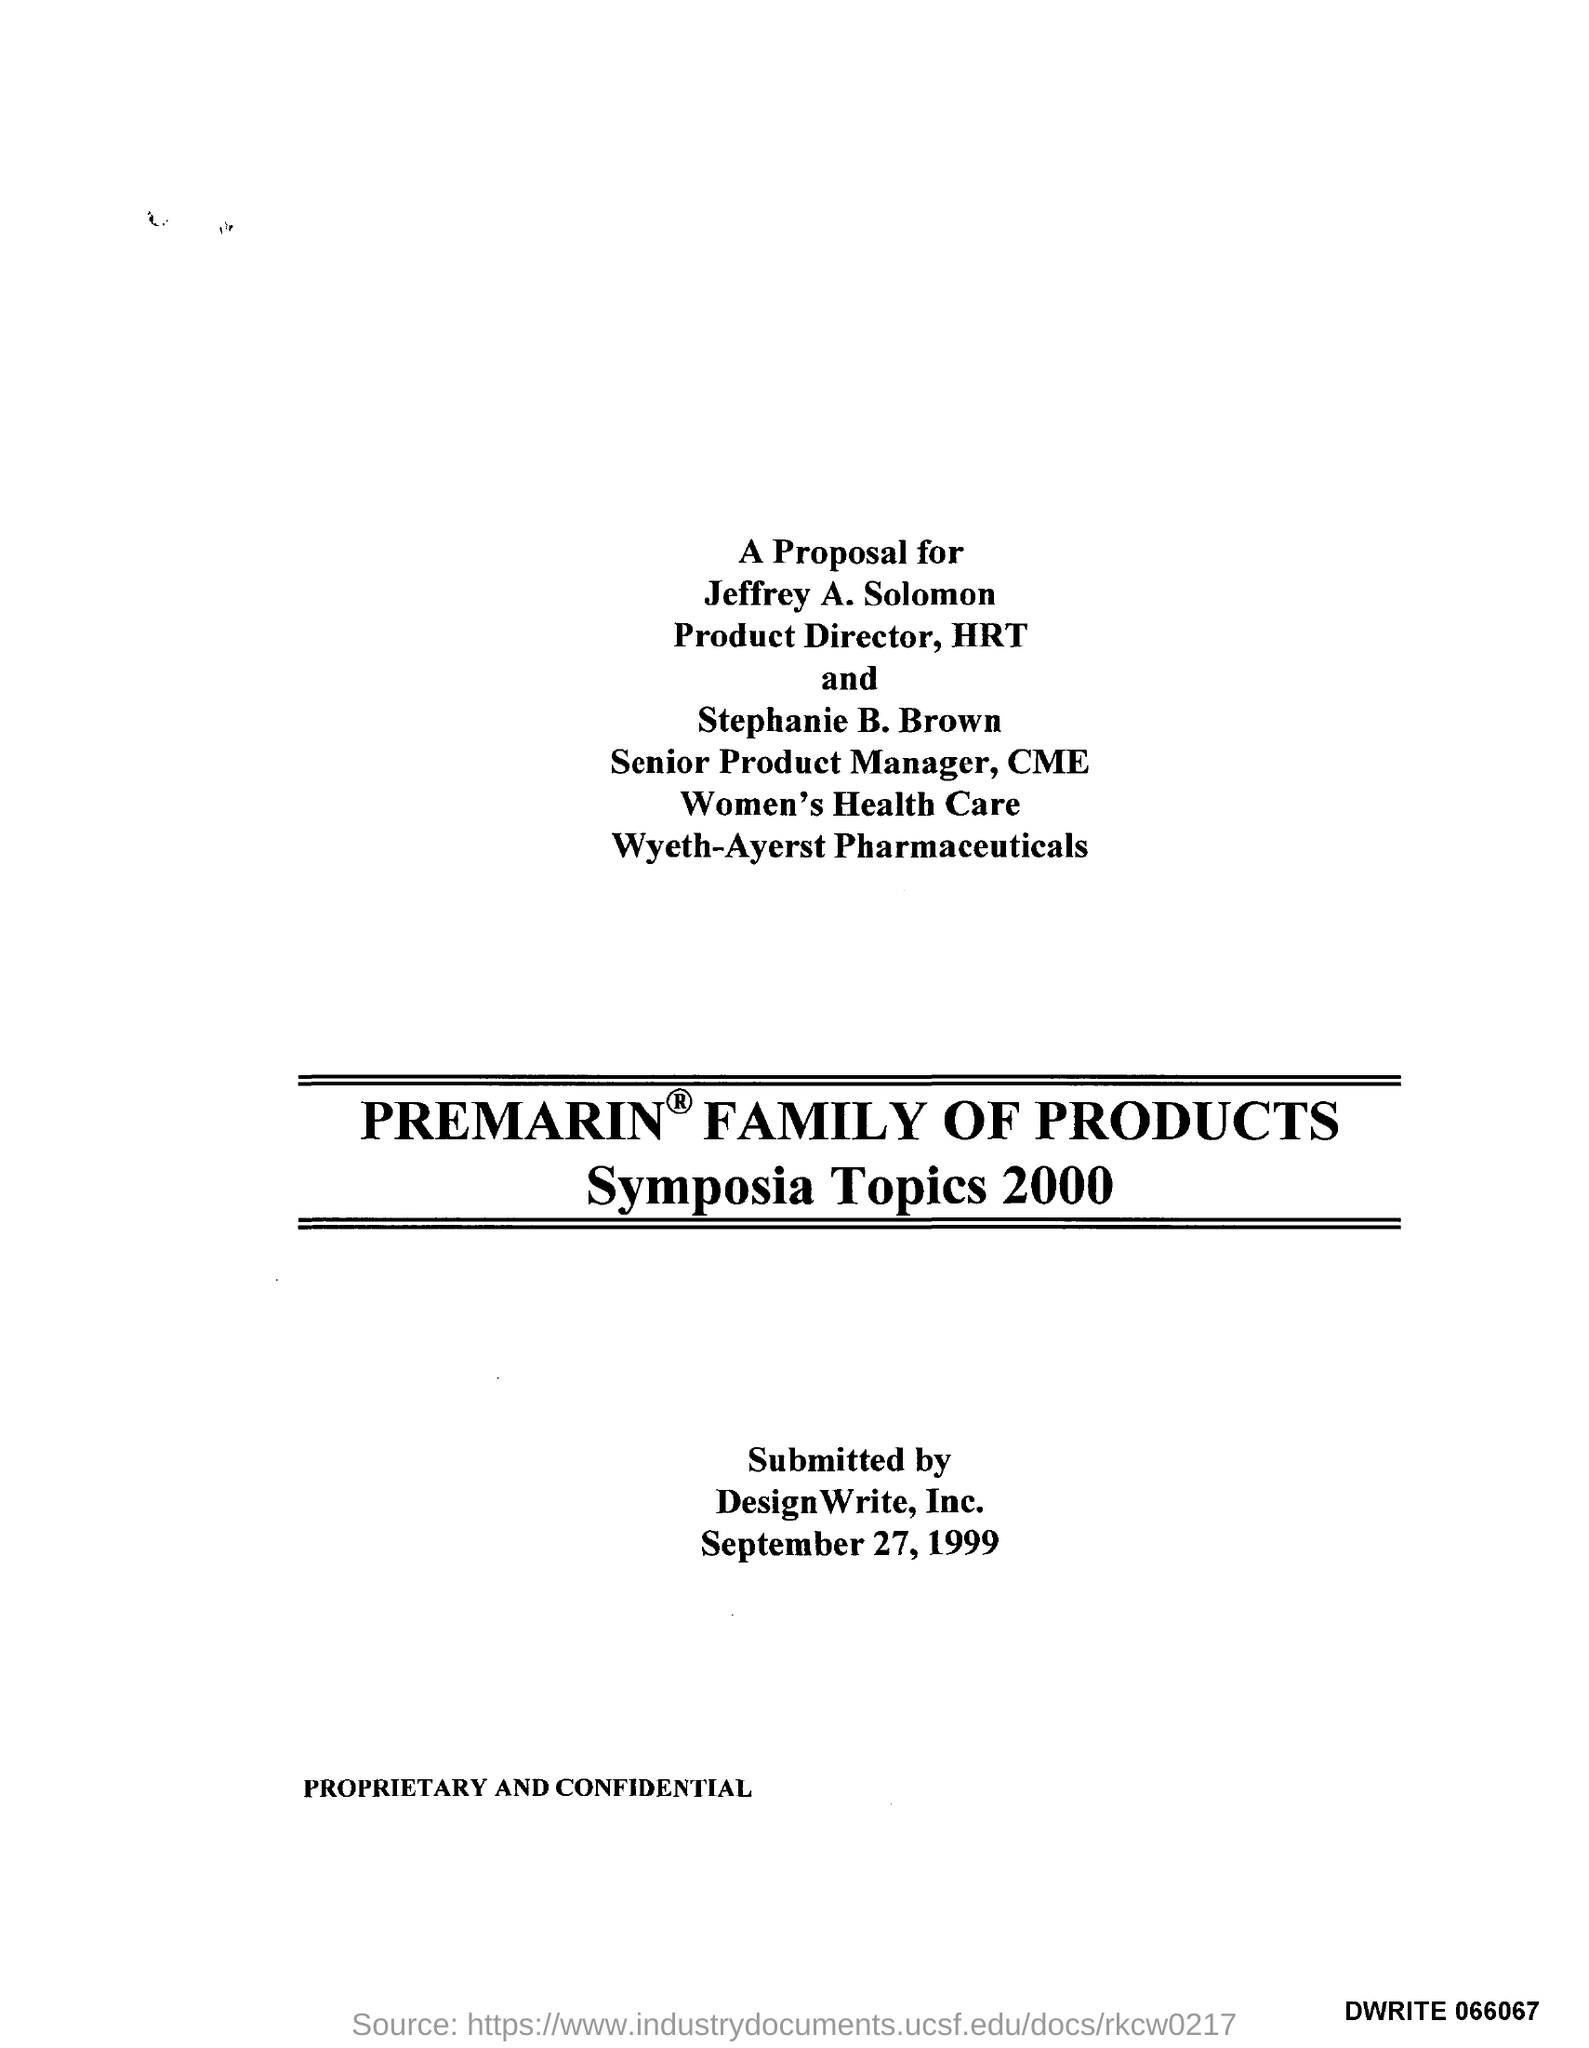Who is it submitted by?
Provide a short and direct response. DesignWrite, Inc. When is it submitted?
Your answer should be very brief. September 27, 1999. 